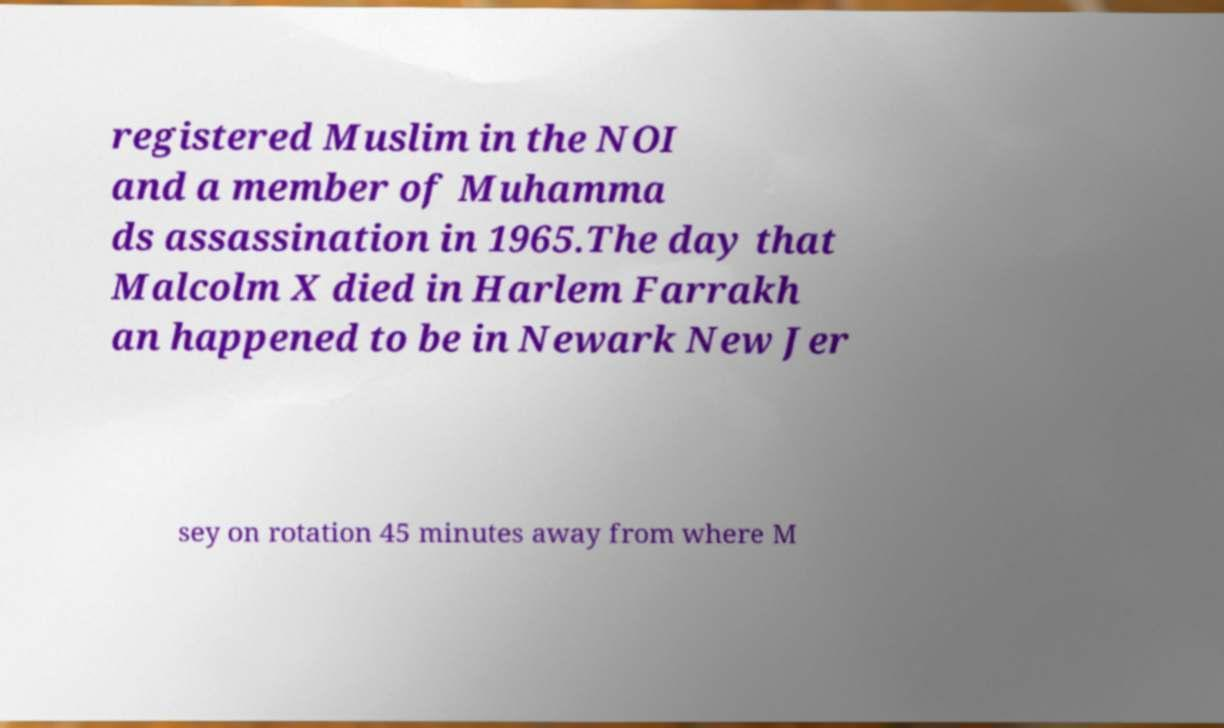Could you assist in decoding the text presented in this image and type it out clearly? registered Muslim in the NOI and a member of Muhamma ds assassination in 1965.The day that Malcolm X died in Harlem Farrakh an happened to be in Newark New Jer sey on rotation 45 minutes away from where M 